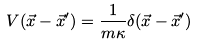<formula> <loc_0><loc_0><loc_500><loc_500>V ( \vec { x } - \vec { x } ^ { \prime } ) = { \frac { 1 } { m \kappa } } \delta ( \vec { x } - \vec { x } ^ { \prime } )</formula> 